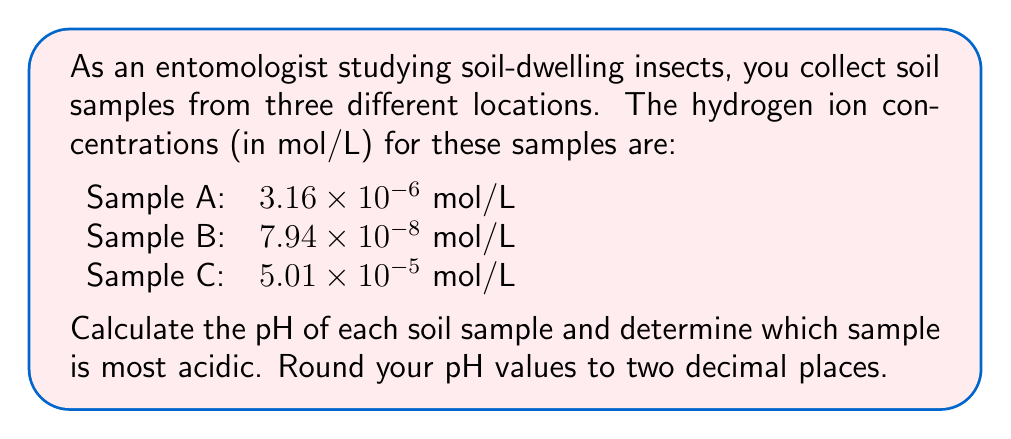Give your solution to this math problem. To solve this problem, we'll use the formula for pH:

$$ pH = -\log_{10}[H^+] $$

Where $[H^+]$ is the hydrogen ion concentration in mol/L.

For Sample A:
$[H^+] = 3.16 \times 10^{-6}$ mol/L
$$ pH = -\log_{10}(3.16 \times 10^{-6}) = 5.50 $$

For Sample B:
$[H^+] = 7.94 \times 10^{-8}$ mol/L
$$ pH = -\log_{10}(7.94 \times 10^{-8}) = 7.10 $$

For Sample C:
$[H^+] = 5.01 \times 10^{-5}$ mol/L
$$ pH = -\log_{10}(5.01 \times 10^{-5}) = 4.30 $$

To determine which sample is most acidic, we compare the pH values. The lowest pH indicates the highest acidity.

Sample A: pH = 5.50
Sample B: pH = 7.10
Sample C: pH = 4.30

Sample C has the lowest pH, making it the most acidic.
Answer: Sample A: pH = 5.50, Sample B: pH = 7.10, Sample C: pH = 4.30. Sample C is most acidic. 